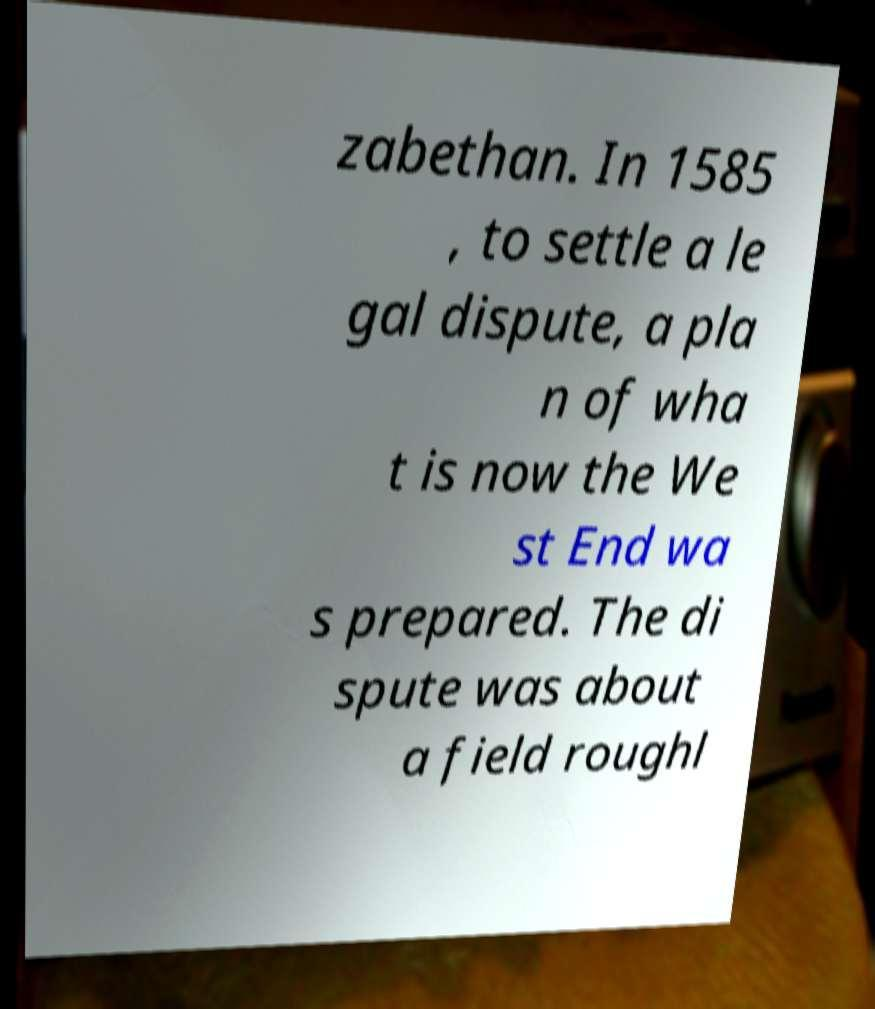Could you extract and type out the text from this image? zabethan. In 1585 , to settle a le gal dispute, a pla n of wha t is now the We st End wa s prepared. The di spute was about a field roughl 